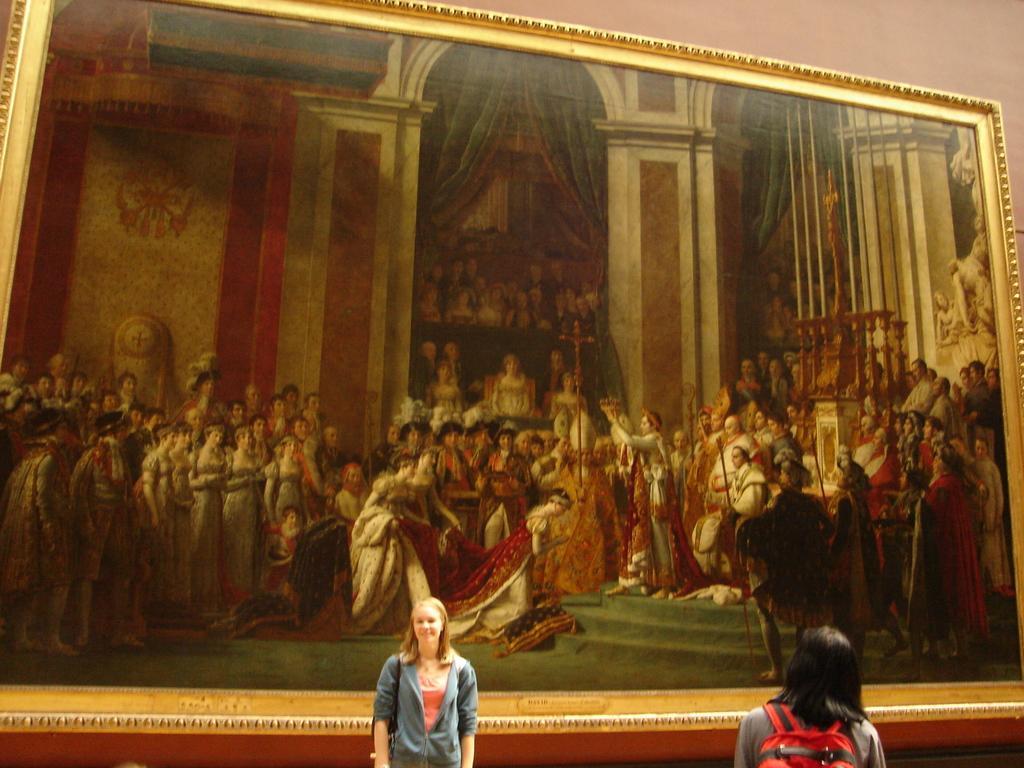Describe this image in one or two sentences. This image consists of two girls. In the background, there is a frame on the wall. In which we can see the depiction of many persons. 